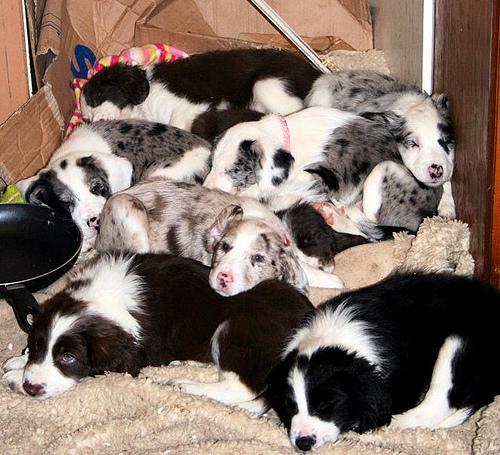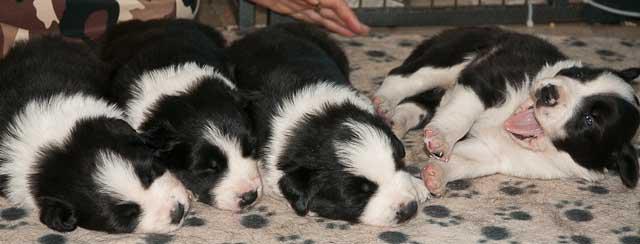The first image is the image on the left, the second image is the image on the right. Analyze the images presented: Is the assertion "An image contains exactly four puppies, all black and white and most of them reclining in a row." valid? Answer yes or no. Yes. 